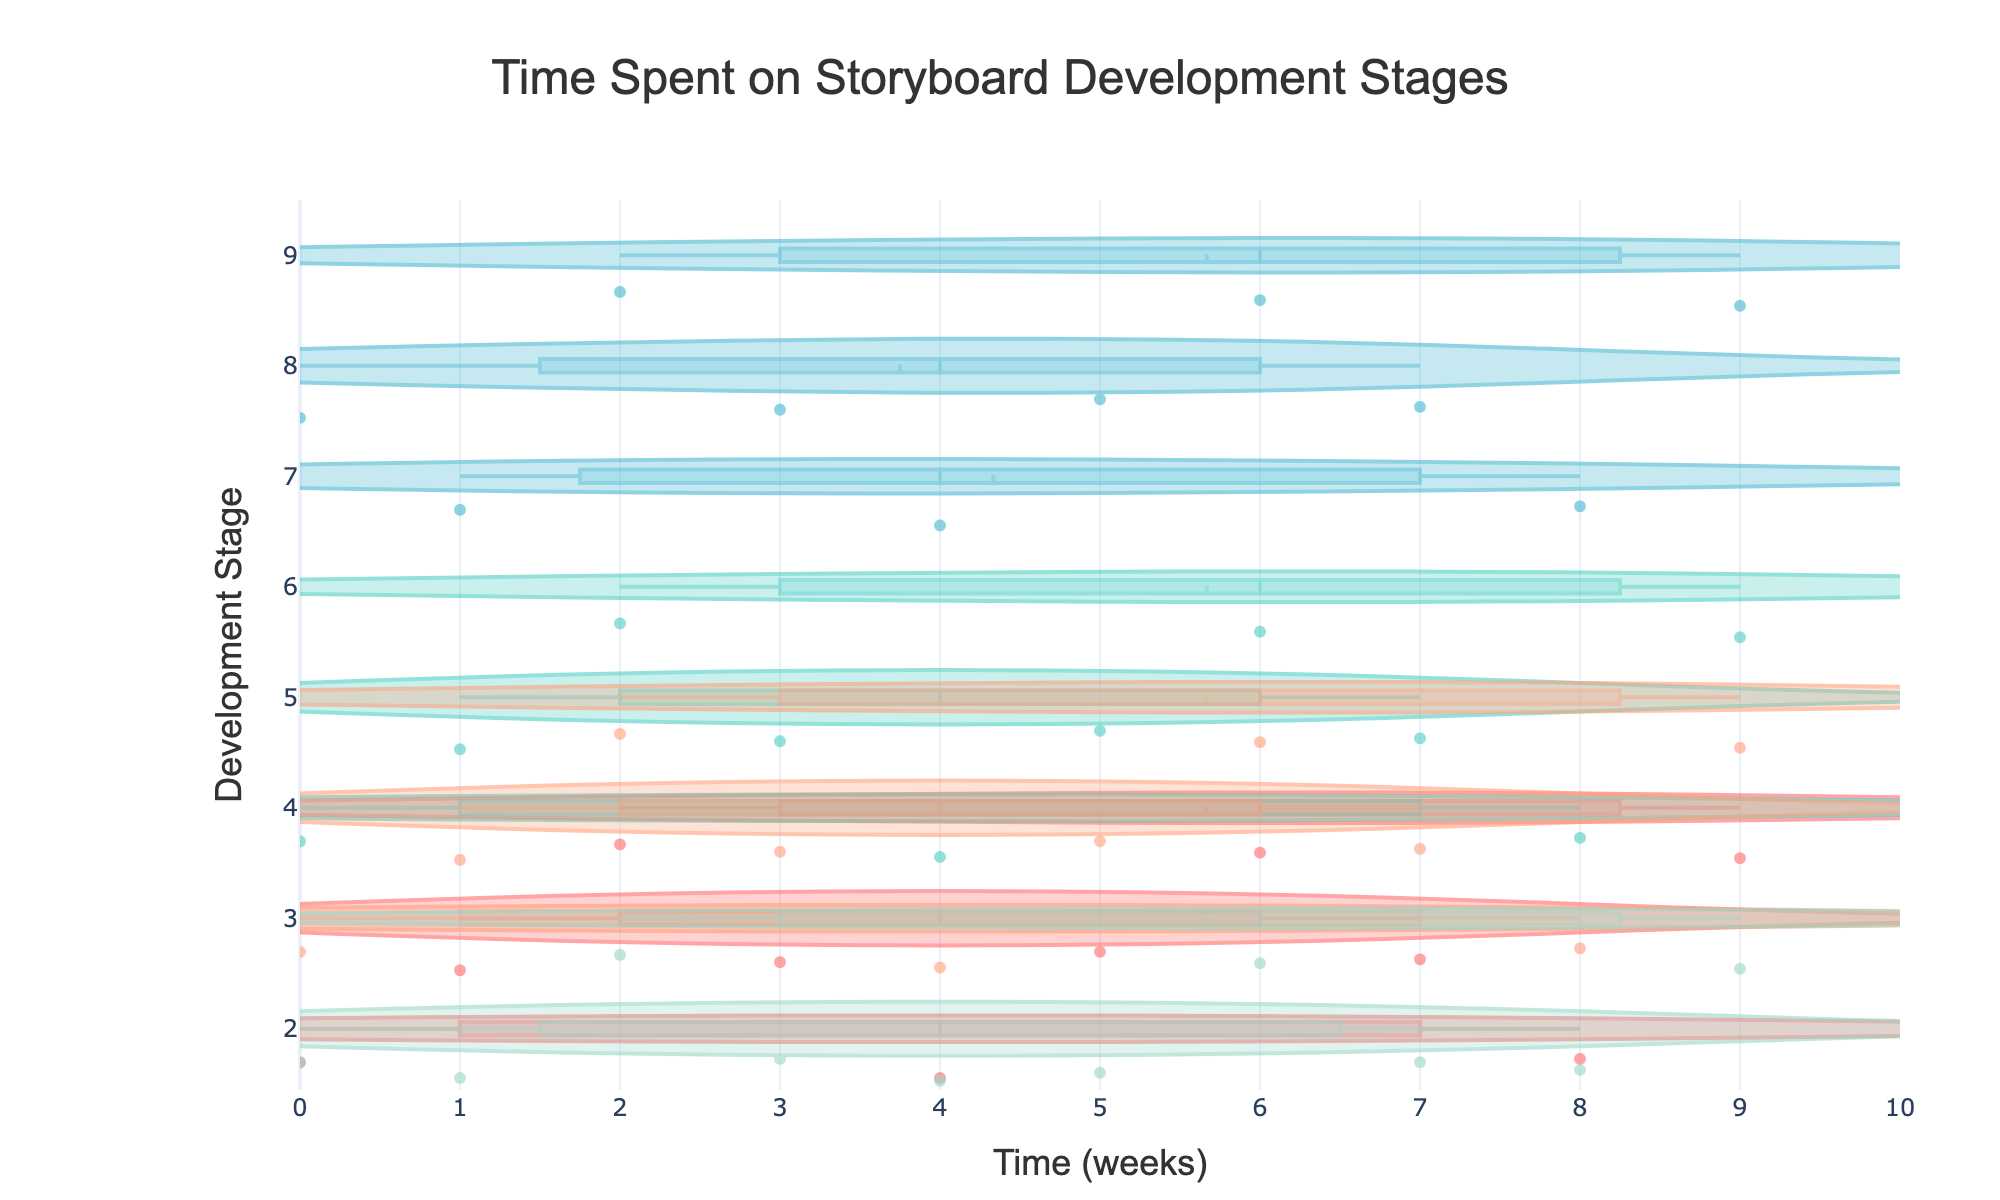What's the title of the plot? The title is positioned at the top center of the figure. It provides a summary of the visualized data.
Answer: Time Spent on Storyboard Development Stages Which development stage has the widest range of time spent? The range can be determined by looking at the spread of the violin plot for each stage. The widest spread represents the widest range.
Answer: Detailed Panels What color represents the Rough Sketches stage? Each stage is represented by a different color in the plot. By identifying the color associated with Rough Sketches, we can decide its representative color.
Answer: Turquoise (light greenish-blue) Which stage has the highest median time spent among all projects? The median is visible as a line within the violin plots. By comparing these median lines across stages, the highest can be identified.
Answer: Detailed Panels On which stage do most projects spend exactly 4 weeks? Dots on the violin plots show individual data points. By locating the dots at the 4-week mark, we can identify which stage has the most points there.
Answer: Rough Sketches How many stages have a median time of 5 weeks or more? The median lines for each stage need to be reviewed to determine how many meet or exceed the 5-week mark.
Answer: Three stages What is the time range for Revisions? The time range for a violin plot can be estimated by the spread of the plot from the lowest to the highest point.
Answer: 3-5 weeks Which stage shows the least variability in time spent? The variability can be inferred from the tightness of the violin plot. The least spread indicates the least variability.
Answer: Final Polishing Compare the median time spent on Concept Development and Final Polishing. Which one is higher? The median line within each violin plot provides this information. By comparing the two, one can find which is higher.
Answer: Concept Development How many stages have individual projects spending at least 9 weeks? Individual data points must be examined to see which stages have dots at the 9-week mark or above.
Answer: Three stages 